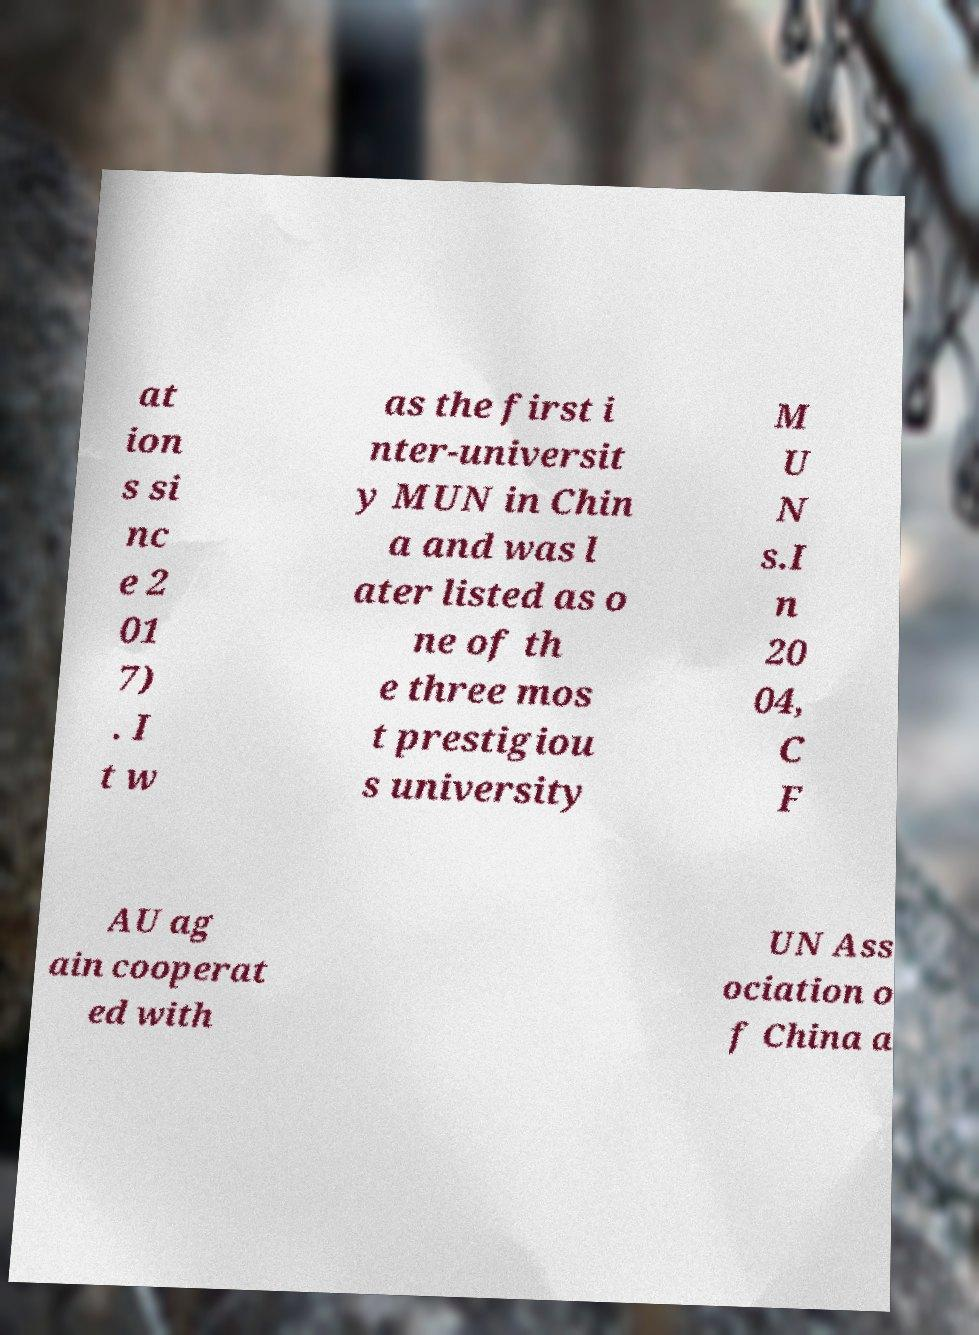Can you read and provide the text displayed in the image?This photo seems to have some interesting text. Can you extract and type it out for me? at ion s si nc e 2 01 7) . I t w as the first i nter-universit y MUN in Chin a and was l ater listed as o ne of th e three mos t prestigiou s university M U N s.I n 20 04, C F AU ag ain cooperat ed with UN Ass ociation o f China a 